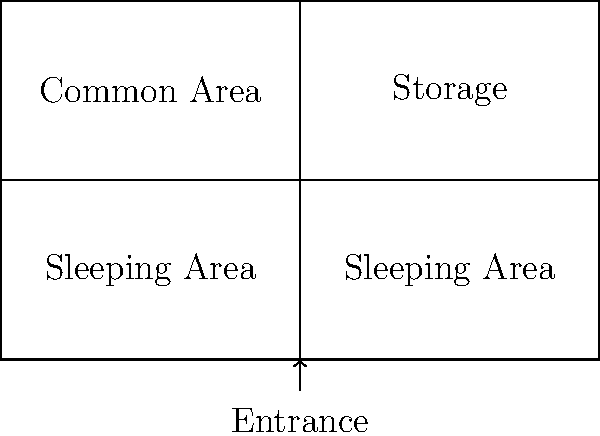In the given layout of a typical military barracks, what is the ratio of sleeping areas to other functional spaces? To determine the ratio of sleeping areas to other functional spaces, we need to follow these steps:

1. Identify the sleeping areas:
   - There are two equal-sized sleeping areas in the lower half of the barracks.

2. Identify other functional spaces:
   - The upper left quadrant is labeled as a common area.
   - The upper right quadrant is labeled as storage.

3. Count the number of equally-sized spaces:
   - Sleeping areas: 2
   - Other functional spaces (common area + storage): 2

4. Calculate the ratio:
   - Ratio = Sleeping areas : Other functional spaces
   - Ratio = 2 : 2
   - This can be simplified to 1 : 1

Therefore, the ratio of sleeping areas to other functional spaces in this typical military barracks layout is 1:1.
Answer: 1:1 